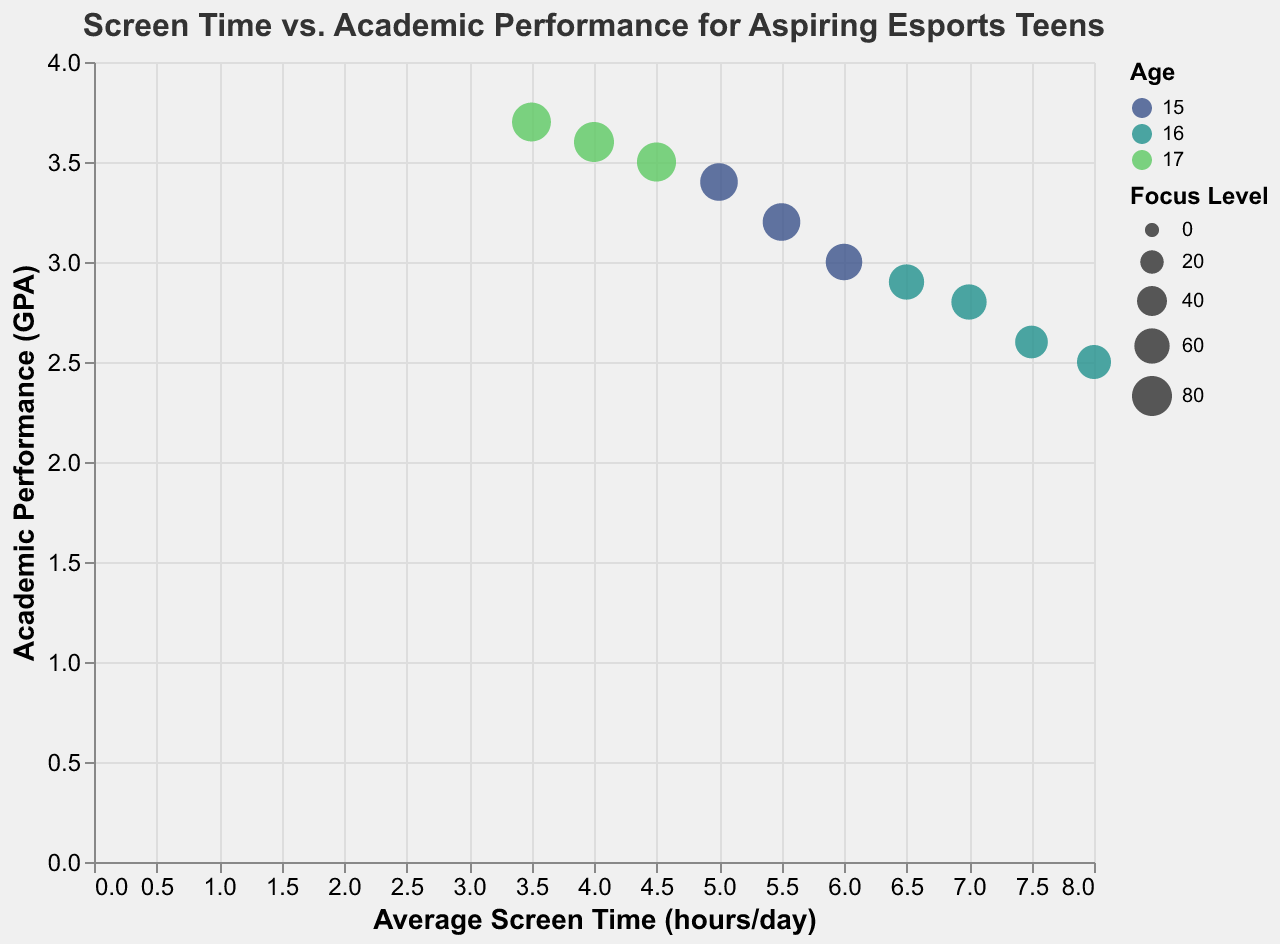What is the title of the chart? The title is located at the top of the chart in a larger font size and typically gives a summary of the content or purpose of the chart. In this case, it is focused on the relationship between average screen time and academic performance for aspiring esports teens.
Answer: Screen Time vs. Academic Performance for Aspiring Esports Teens Which hobby is associated with the highest GPA? To determine this, look for the highest point on the y-axis (GPA) and note the associated tooltip information or legend denoting the hobby.
Answer: Dance How does average screen time influence academic performance (GPA) among the teenagers? Observe the overall trend or pattern in the scatter plot by examining how the GPA values change with different screen times. If the GPA tends to decrease with increasing screen time, it indicates a negative correlation.
Answer: Negative correlation Who has the highest focus level and what is their screen time and GPA? Identify the data point with the largest bubble size (since size represents focus level) and check the tooltip information to note the screen time and GPA.
Answer: Michael; 4.0 hours/day; 3.6 GPA Compare the academic performance of the teens at age 15 to those at age 16. Who generally has better GPA? Observe the color legend to differentiate between the ages, then compare the vertical positions (GPA) of the data points corresponding to ages 15 and 16.
Answer: Teens at age 15 What is the range of average screen time among all the aspiring esports teens? Note the minimum and maximum values on the x-axis to determine the range of average screen time.
Answer: 3.5 to 8.0 hours/day Which individual has the lowest GPA and what is their average screen time? Locate the data point at the lowest position on the y-axis (GPA) and check the tooltip information for their average screen time.
Answer: Daniel; 8.0 hours/day 